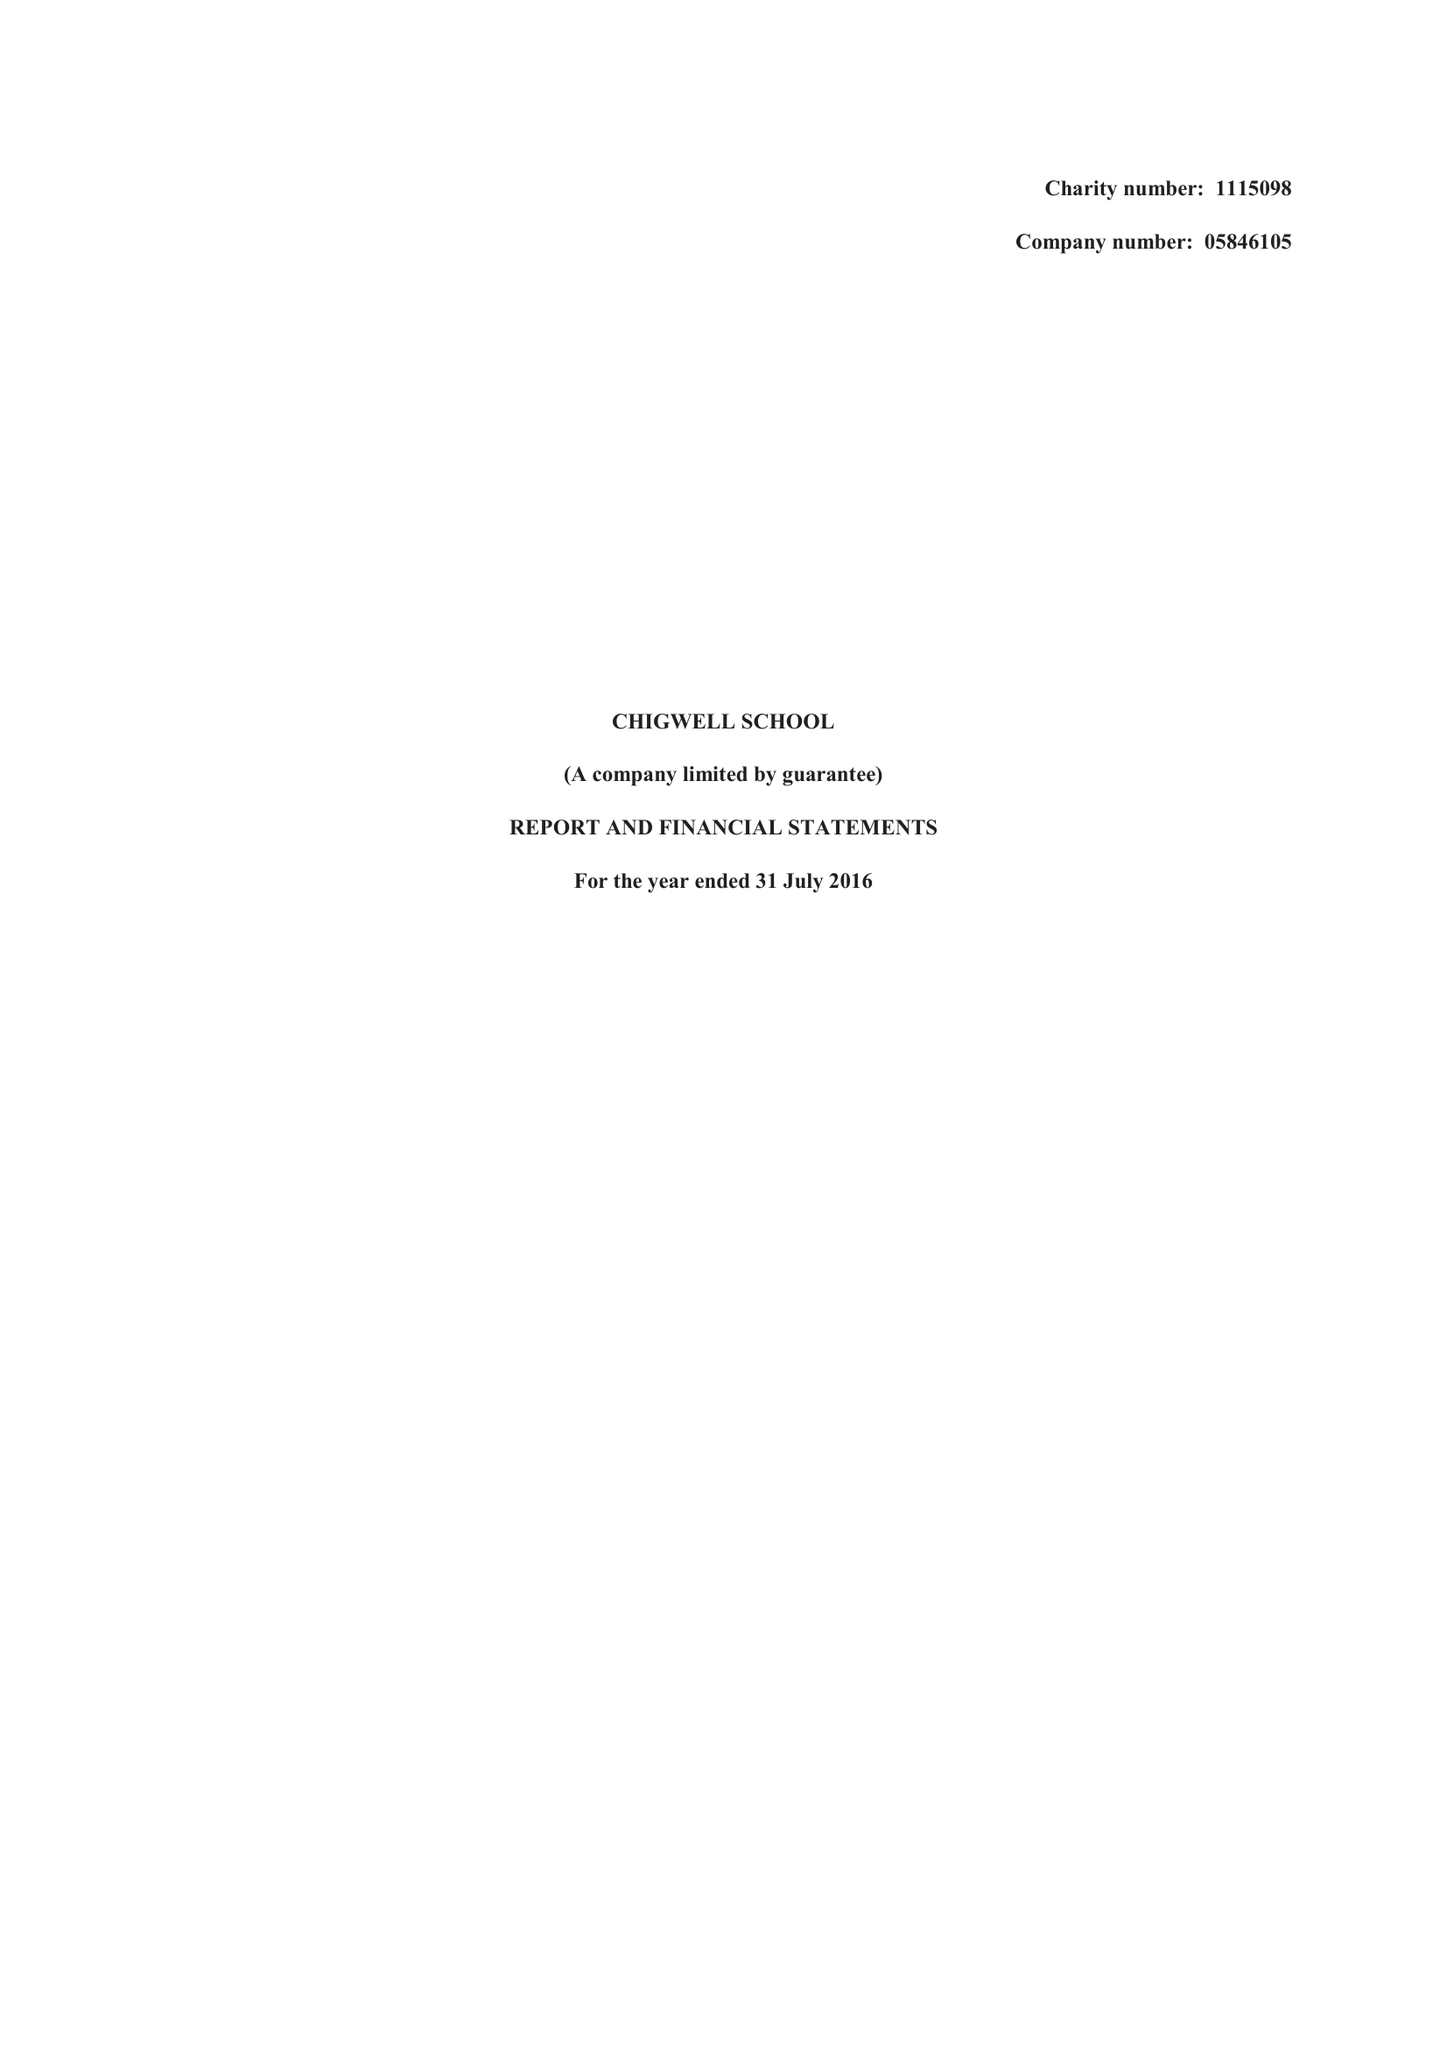What is the value for the address__street_line?
Answer the question using a single word or phrase. HIGH ROAD 